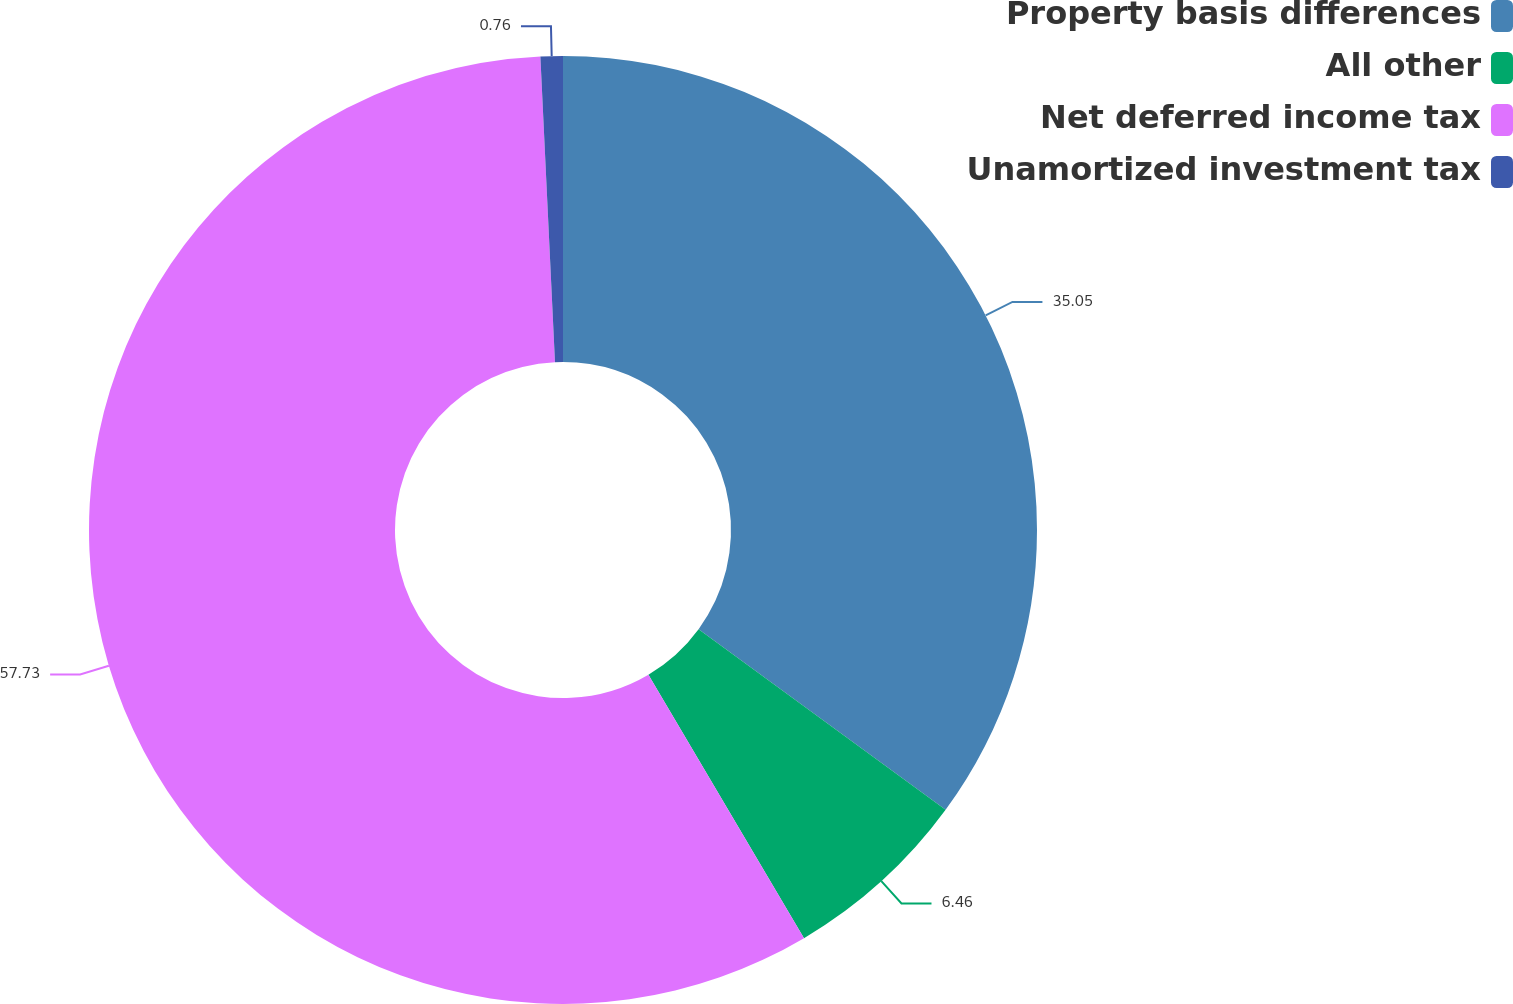<chart> <loc_0><loc_0><loc_500><loc_500><pie_chart><fcel>Property basis differences<fcel>All other<fcel>Net deferred income tax<fcel>Unamortized investment tax<nl><fcel>35.05%<fcel>6.46%<fcel>57.73%<fcel>0.76%<nl></chart> 